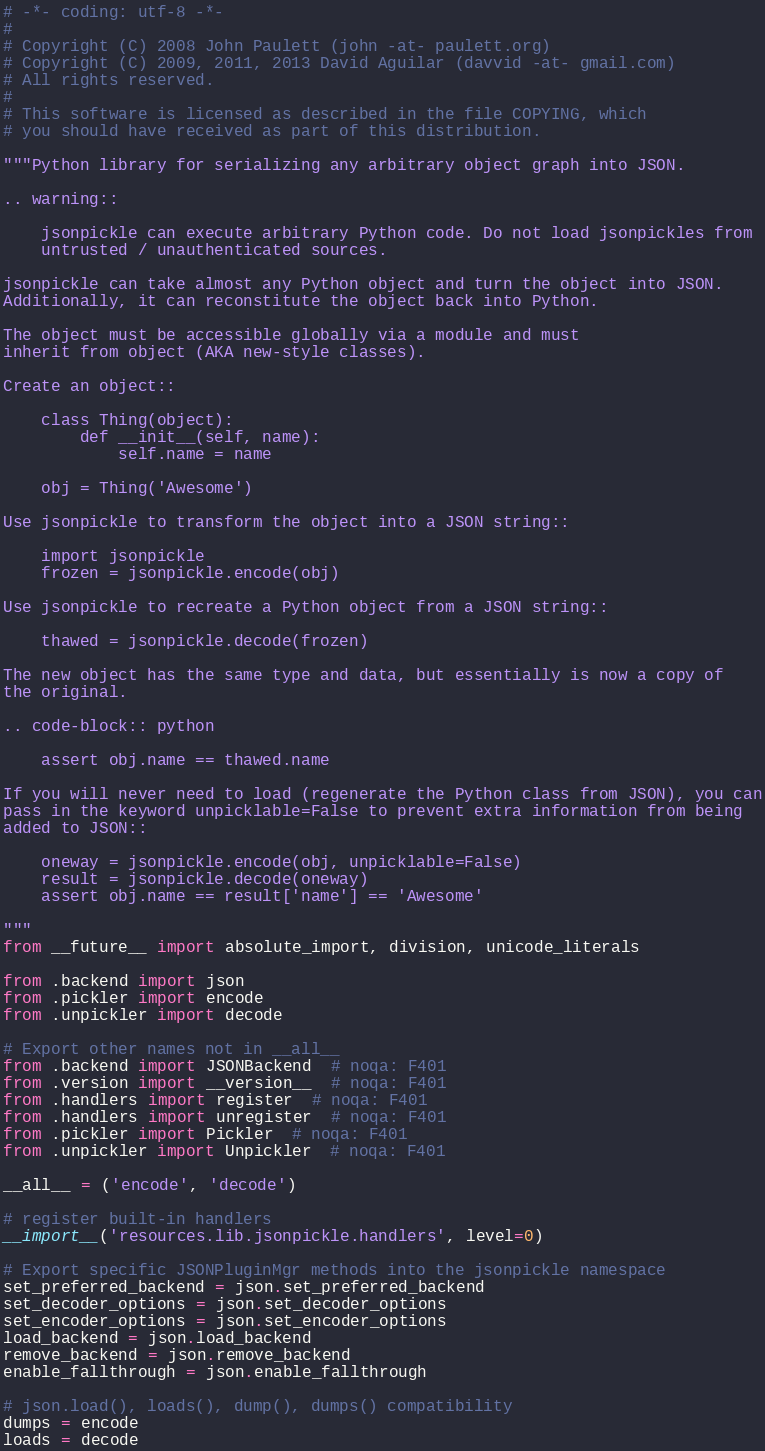<code> <loc_0><loc_0><loc_500><loc_500><_Python_># -*- coding: utf-8 -*-
#
# Copyright (C) 2008 John Paulett (john -at- paulett.org)
# Copyright (C) 2009, 2011, 2013 David Aguilar (davvid -at- gmail.com)
# All rights reserved.
#
# This software is licensed as described in the file COPYING, which
# you should have received as part of this distribution.

"""Python library for serializing any arbitrary object graph into JSON.

.. warning::

    jsonpickle can execute arbitrary Python code. Do not load jsonpickles from
    untrusted / unauthenticated sources.

jsonpickle can take almost any Python object and turn the object into JSON.
Additionally, it can reconstitute the object back into Python.

The object must be accessible globally via a module and must
inherit from object (AKA new-style classes).

Create an object::

    class Thing(object):
        def __init__(self, name):
            self.name = name

    obj = Thing('Awesome')

Use jsonpickle to transform the object into a JSON string::

    import jsonpickle
    frozen = jsonpickle.encode(obj)

Use jsonpickle to recreate a Python object from a JSON string::

    thawed = jsonpickle.decode(frozen)

The new object has the same type and data, but essentially is now a copy of
the original.

.. code-block:: python

    assert obj.name == thawed.name

If you will never need to load (regenerate the Python class from JSON), you can
pass in the keyword unpicklable=False to prevent extra information from being
added to JSON::

    oneway = jsonpickle.encode(obj, unpicklable=False)
    result = jsonpickle.decode(oneway)
    assert obj.name == result['name'] == 'Awesome'

"""
from __future__ import absolute_import, division, unicode_literals

from .backend import json
from .pickler import encode
from .unpickler import decode

# Export other names not in __all__
from .backend import JSONBackend  # noqa: F401
from .version import __version__  # noqa: F401
from .handlers import register  # noqa: F401
from .handlers import unregister  # noqa: F401
from .pickler import Pickler  # noqa: F401
from .unpickler import Unpickler  # noqa: F401

__all__ = ('encode', 'decode')

# register built-in handlers
__import__('resources.lib.jsonpickle.handlers', level=0)

# Export specific JSONPluginMgr methods into the jsonpickle namespace
set_preferred_backend = json.set_preferred_backend
set_decoder_options = json.set_decoder_options
set_encoder_options = json.set_encoder_options
load_backend = json.load_backend
remove_backend = json.remove_backend
enable_fallthrough = json.enable_fallthrough

# json.load(), loads(), dump(), dumps() compatibility
dumps = encode
loads = decode
</code> 